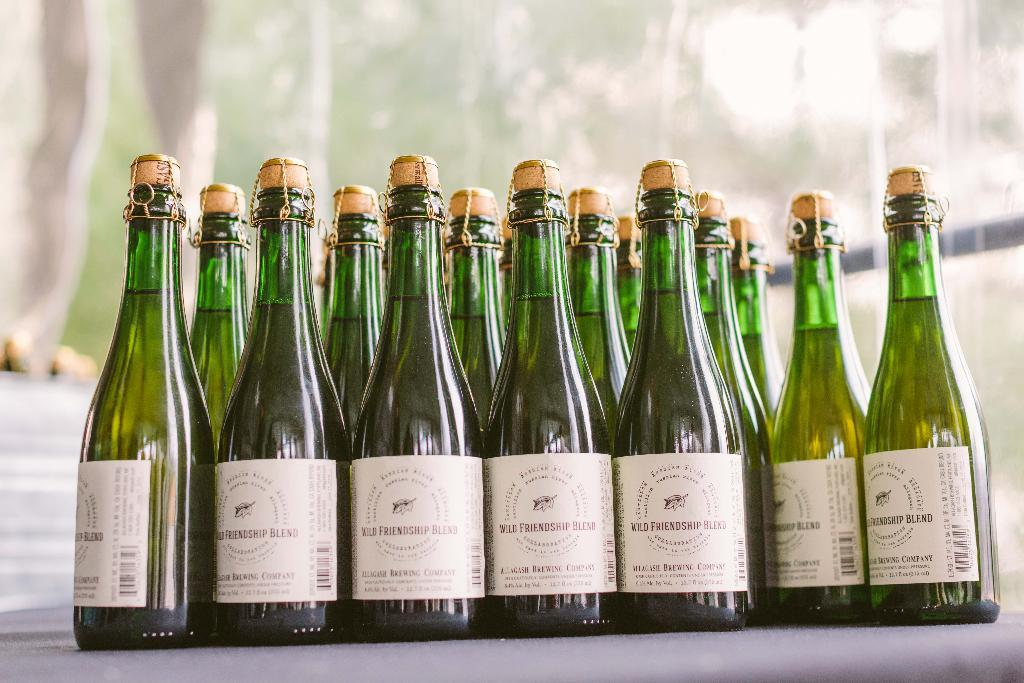What type of setting is depicted in the image? The image appears to be of an outdoor setting. What objects can be seen in the foreground of the image? There are bottles containing drinks in the foreground. Where are the bottles placed in the image? The bottles are placed on top of a table. What can be seen in the background of the image? There are trees visible in the background. Can you see any planes in the image? No, there are no planes visible in the image. 